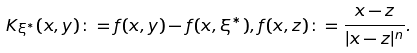Convert formula to latex. <formula><loc_0><loc_0><loc_500><loc_500>K _ { \xi ^ { * } } ( x , y ) \colon = f ( x , y ) - f ( x , \xi ^ { * } ) , f ( x , z ) \colon = \frac { x - z } { | x - z | ^ { n } } .</formula> 